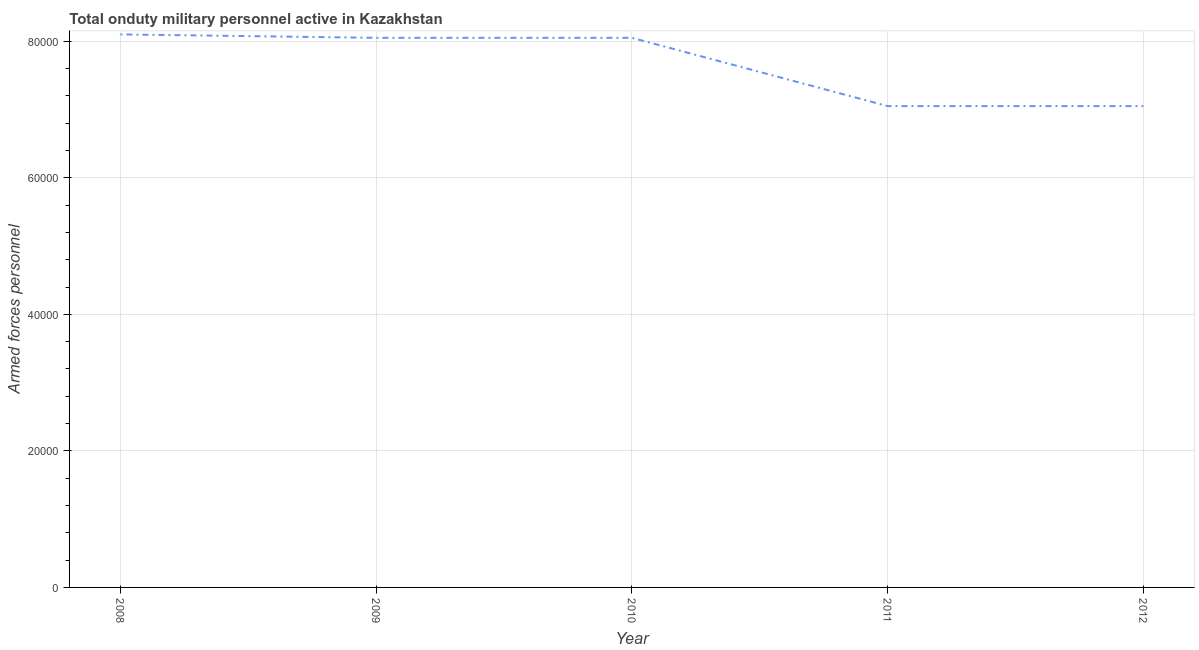What is the number of armed forces personnel in 2012?
Provide a succinct answer. 7.05e+04. Across all years, what is the maximum number of armed forces personnel?
Your response must be concise. 8.10e+04. Across all years, what is the minimum number of armed forces personnel?
Your response must be concise. 7.05e+04. What is the sum of the number of armed forces personnel?
Offer a very short reply. 3.83e+05. What is the difference between the number of armed forces personnel in 2009 and 2011?
Provide a succinct answer. 10000. What is the average number of armed forces personnel per year?
Keep it short and to the point. 7.66e+04. What is the median number of armed forces personnel?
Make the answer very short. 8.05e+04. Do a majority of the years between 2011 and 2008 (inclusive) have number of armed forces personnel greater than 12000 ?
Make the answer very short. Yes. What is the ratio of the number of armed forces personnel in 2009 to that in 2012?
Offer a very short reply. 1.14. Is the number of armed forces personnel in 2009 less than that in 2011?
Give a very brief answer. No. What is the difference between the highest and the second highest number of armed forces personnel?
Offer a terse response. 500. Is the sum of the number of armed forces personnel in 2009 and 2012 greater than the maximum number of armed forces personnel across all years?
Provide a short and direct response. Yes. What is the difference between the highest and the lowest number of armed forces personnel?
Provide a succinct answer. 1.05e+04. How many lines are there?
Provide a succinct answer. 1. What is the difference between two consecutive major ticks on the Y-axis?
Offer a terse response. 2.00e+04. Are the values on the major ticks of Y-axis written in scientific E-notation?
Provide a succinct answer. No. Does the graph contain any zero values?
Make the answer very short. No. What is the title of the graph?
Offer a very short reply. Total onduty military personnel active in Kazakhstan. What is the label or title of the Y-axis?
Your answer should be compact. Armed forces personnel. What is the Armed forces personnel in 2008?
Provide a short and direct response. 8.10e+04. What is the Armed forces personnel in 2009?
Your answer should be very brief. 8.05e+04. What is the Armed forces personnel of 2010?
Provide a succinct answer. 8.05e+04. What is the Armed forces personnel in 2011?
Provide a short and direct response. 7.05e+04. What is the Armed forces personnel of 2012?
Your response must be concise. 7.05e+04. What is the difference between the Armed forces personnel in 2008 and 2009?
Give a very brief answer. 500. What is the difference between the Armed forces personnel in 2008 and 2010?
Give a very brief answer. 500. What is the difference between the Armed forces personnel in 2008 and 2011?
Give a very brief answer. 1.05e+04. What is the difference between the Armed forces personnel in 2008 and 2012?
Your response must be concise. 1.05e+04. What is the difference between the Armed forces personnel in 2009 and 2010?
Your answer should be compact. 0. What is the difference between the Armed forces personnel in 2009 and 2012?
Ensure brevity in your answer.  10000. What is the difference between the Armed forces personnel in 2010 and 2011?
Your answer should be compact. 10000. What is the difference between the Armed forces personnel in 2010 and 2012?
Give a very brief answer. 10000. What is the ratio of the Armed forces personnel in 2008 to that in 2009?
Provide a succinct answer. 1.01. What is the ratio of the Armed forces personnel in 2008 to that in 2010?
Your response must be concise. 1.01. What is the ratio of the Armed forces personnel in 2008 to that in 2011?
Provide a succinct answer. 1.15. What is the ratio of the Armed forces personnel in 2008 to that in 2012?
Your answer should be very brief. 1.15. What is the ratio of the Armed forces personnel in 2009 to that in 2011?
Provide a short and direct response. 1.14. What is the ratio of the Armed forces personnel in 2009 to that in 2012?
Give a very brief answer. 1.14. What is the ratio of the Armed forces personnel in 2010 to that in 2011?
Give a very brief answer. 1.14. What is the ratio of the Armed forces personnel in 2010 to that in 2012?
Offer a very short reply. 1.14. 